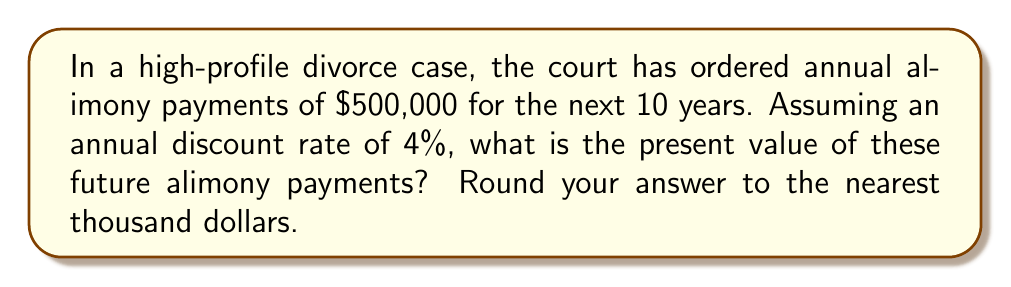Provide a solution to this math problem. To calculate the present value of future alimony payments, we need to use the discounted cash flow (DCF) analysis. The formula for the present value of a series of equal payments is:

$$PV = A \cdot \frac{1 - (1+r)^{-n}}{r}$$

Where:
$PV$ = Present Value
$A$ = Annual payment amount
$r$ = Annual discount rate
$n$ = Number of years

Given:
$A = \$500,000$
$r = 4\% = 0.04$
$n = 10$ years

Let's substitute these values into the formula:

$$PV = 500,000 \cdot \frac{1 - (1+0.04)^{-10}}{0.04}$$

Now, let's solve this step-by-step:

1. Calculate $(1+0.04)^{-10}$:
   $$(1.04)^{-10} \approx 0.6756$$

2. Subtract this value from 1:
   $$1 - 0.6756 = 0.3244$$

3. Divide by the discount rate:
   $$\frac{0.3244}{0.04} = 8.1100$$

4. Multiply by the annual payment:
   $$500,000 \cdot 8.1100 = 4,055,000$$

Therefore, the present value of the future alimony payments is $4,055,000.

Rounding to the nearest thousand dollars gives us $4,055,000.
Answer: $4,055,000 